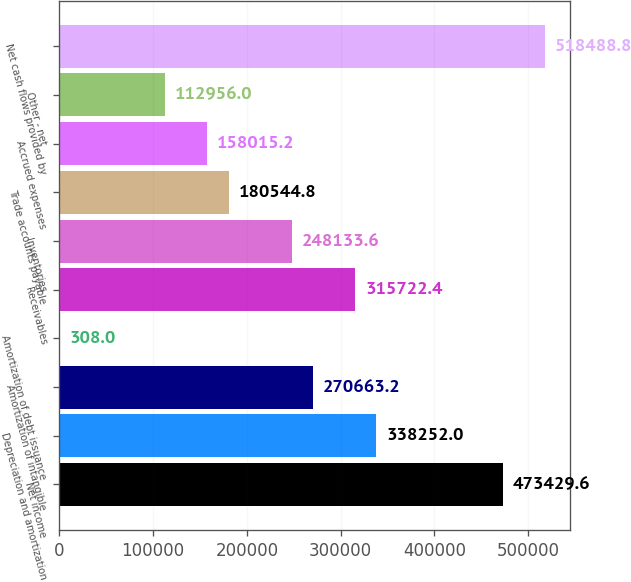Convert chart. <chart><loc_0><loc_0><loc_500><loc_500><bar_chart><fcel>Net income<fcel>Depreciation and amortization<fcel>Amortization of intangible<fcel>Amortization of debt issuance<fcel>Receivables<fcel>Inventories<fcel>Trade accounts payable<fcel>Accrued expenses<fcel>Other - net<fcel>Net cash flows provided by<nl><fcel>473430<fcel>338252<fcel>270663<fcel>308<fcel>315722<fcel>248134<fcel>180545<fcel>158015<fcel>112956<fcel>518489<nl></chart> 